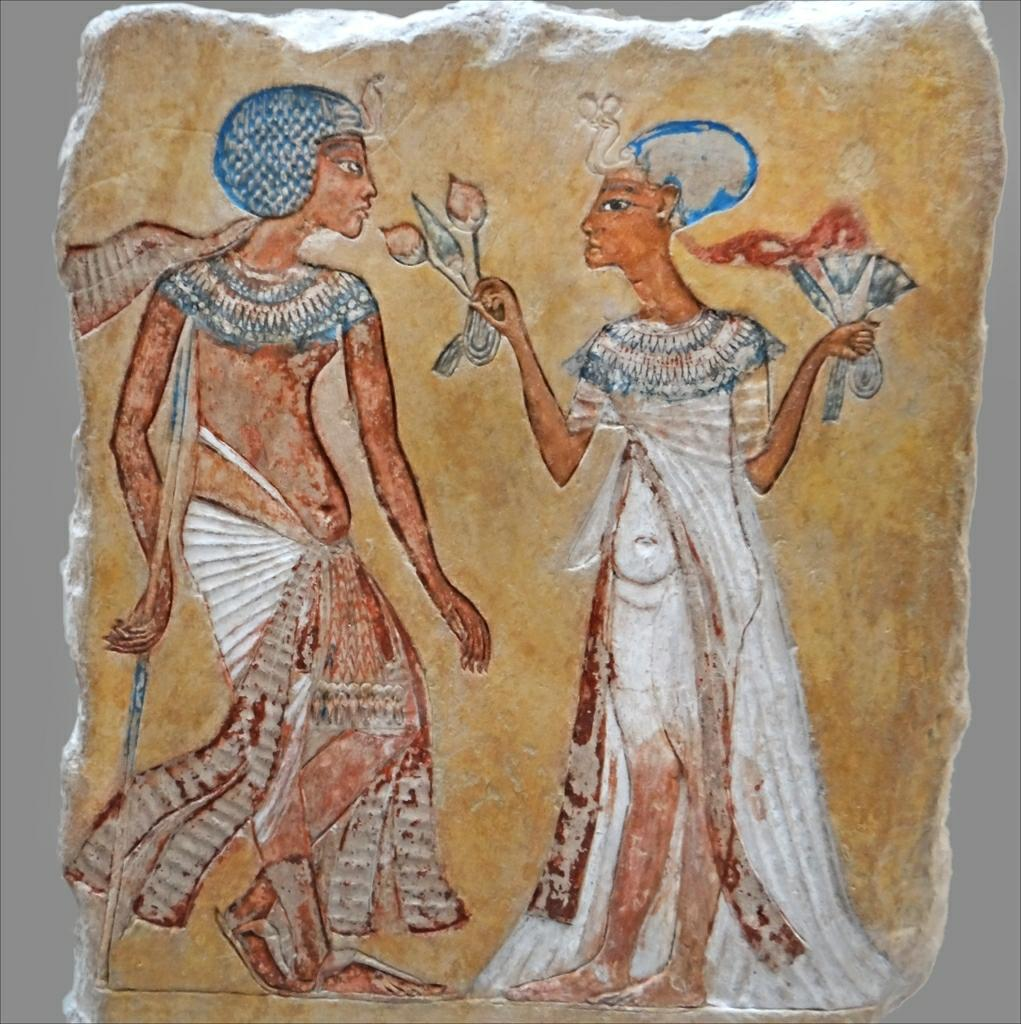What is the main subject of the image? There is an art piece in the image. What does the art piece depict? The art piece depicts a man and a woman. On what surface is the art piece placed? The art piece is on a stone surface. What is the color of the background in the image? The background of the image is white in color. What type of sky can be seen in the image? There is no sky visible in the image, as the background is white in color. What experience does the man and woman in the art piece share? The image does not provide any information about the experience shared by the man and woman in the art piece. 